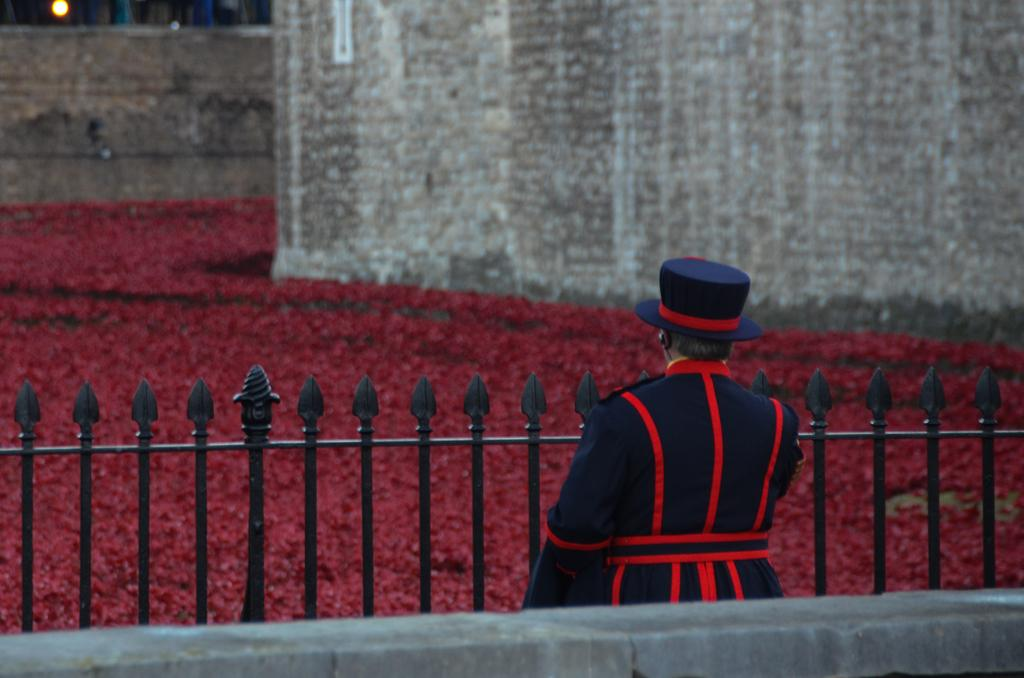What is the main subject of the image? There is a man standing in the image. What is the man wearing? The man is wearing a uniform. What can be seen in the foreground of the image? There are grilles in the image. What type of vegetation is visible in the background of the image? There are hedges in the background of the image. What type of structure is visible in the background of the image? There are walls visible in the background of the image. What is the source of light in the image? There is a light at the top of the image. Can you tell me how many clovers are growing in the image? There are no clovers present in the image. What type of trains can be seen passing by in the image? There are no trains visible in the image. 